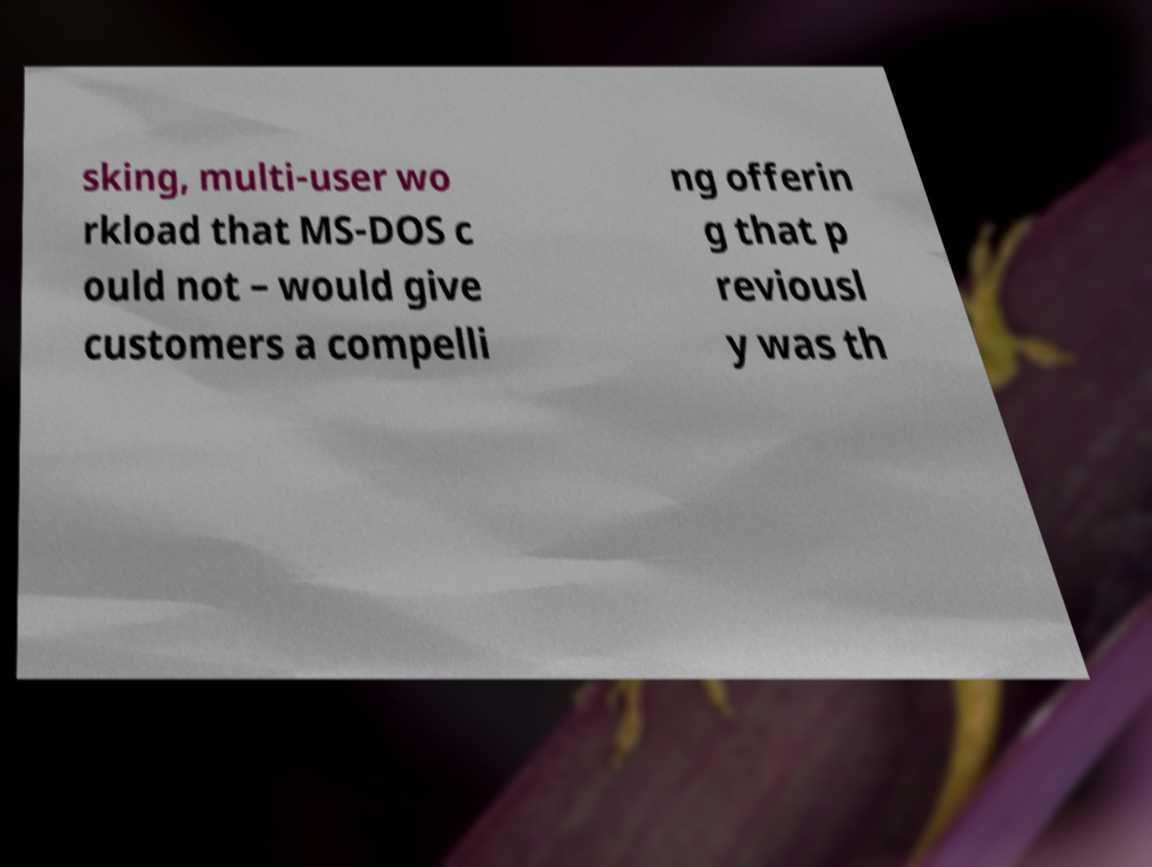Could you assist in decoding the text presented in this image and type it out clearly? sking, multi-user wo rkload that MS-DOS c ould not – would give customers a compelli ng offerin g that p reviousl y was th 